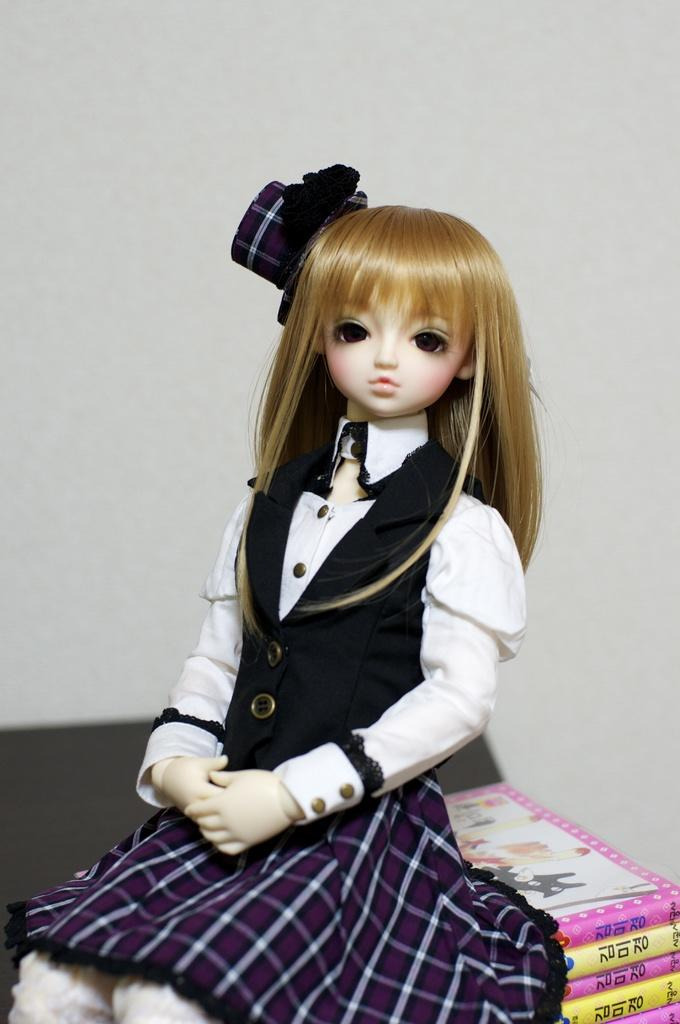What is the main subject in the middle of the image? There is a toy in the middle of the image. Are there any other objects present in the middle of the image? Yes, there are boxes in the middle of the image. What type of squirrel can be seen climbing on the toy in the image? There is no squirrel present in the image; it only features a toy and boxes. 